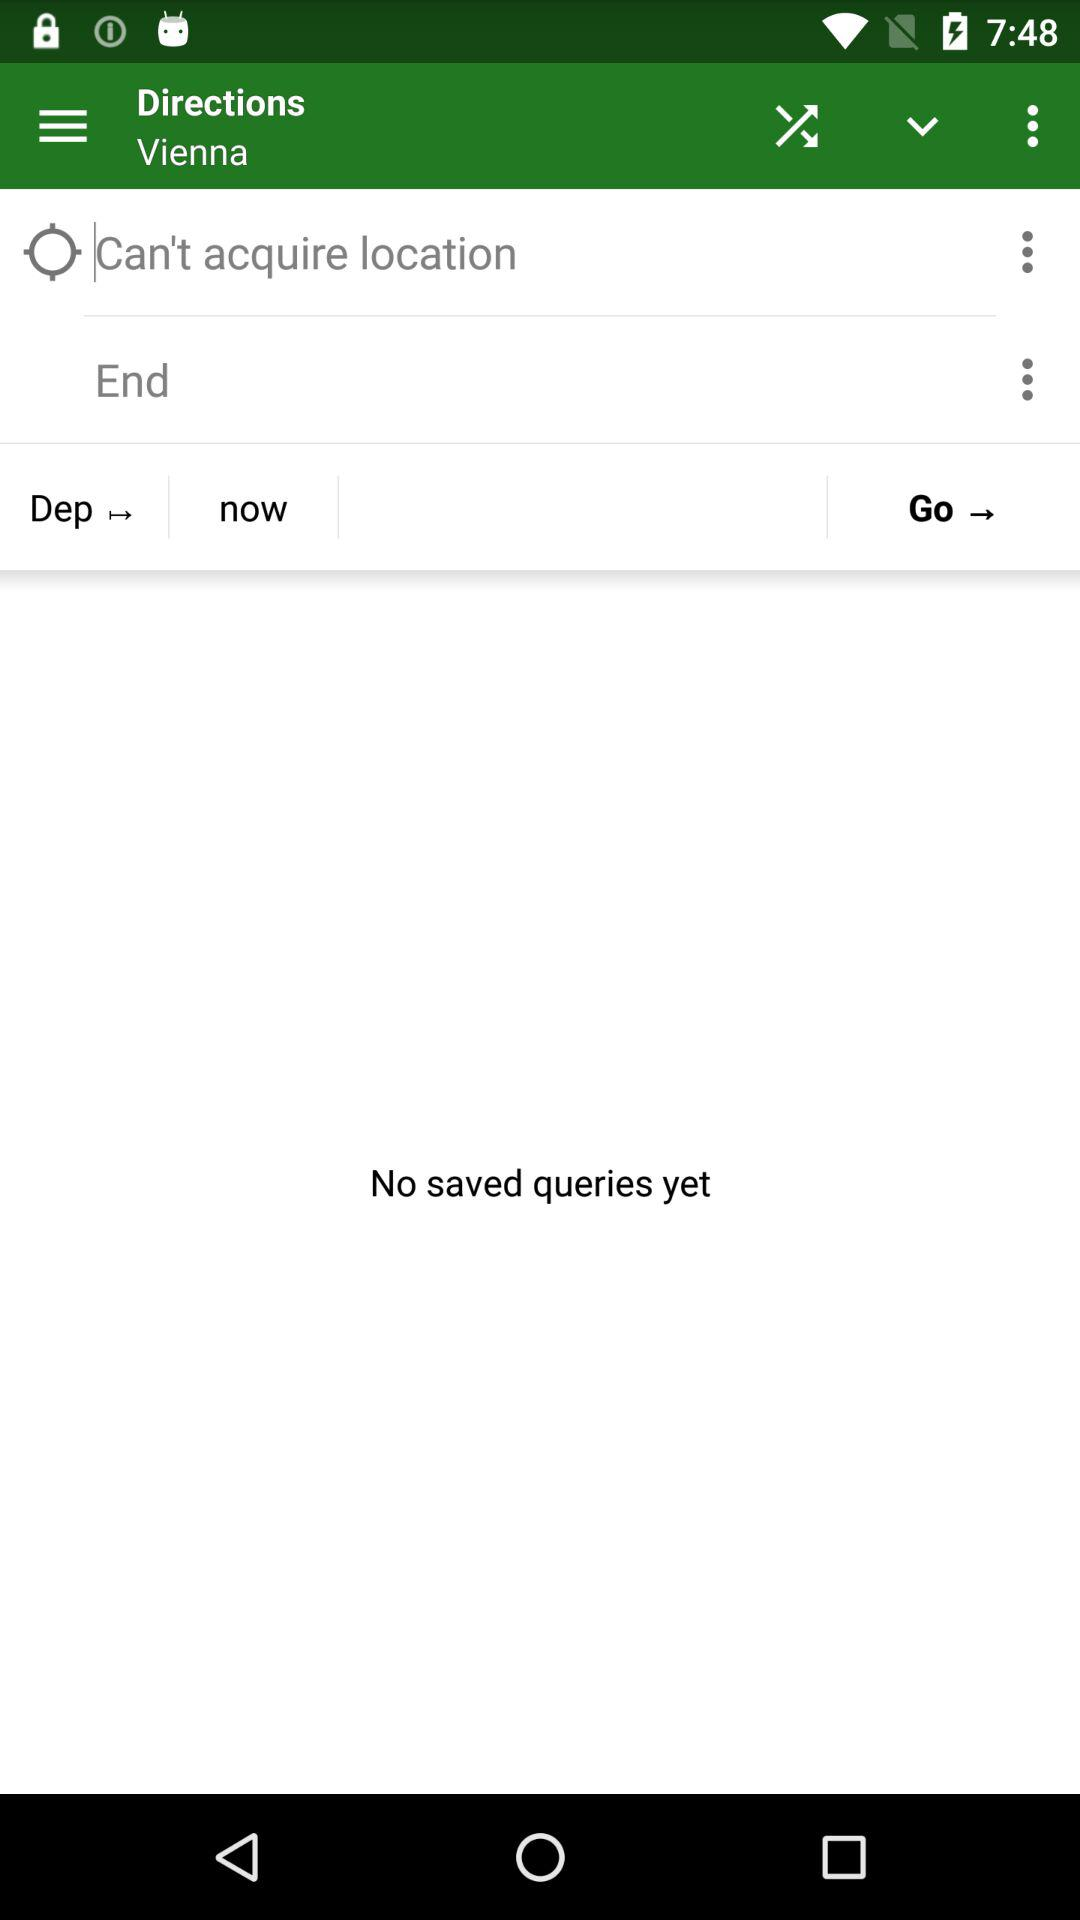What is the mentioned location? The mentioned location is Vienna. 